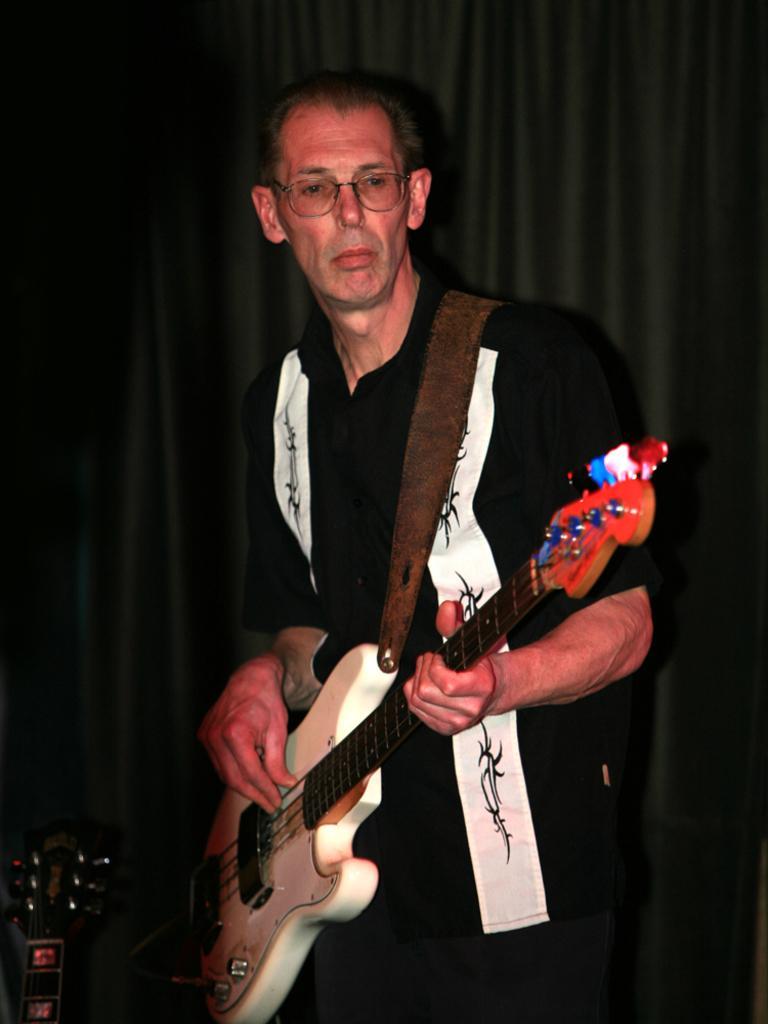Could you give a brief overview of what you see in this image? In this image i can see a person standing and holding a guitar in his hand. In the background i can see a black curtain. 